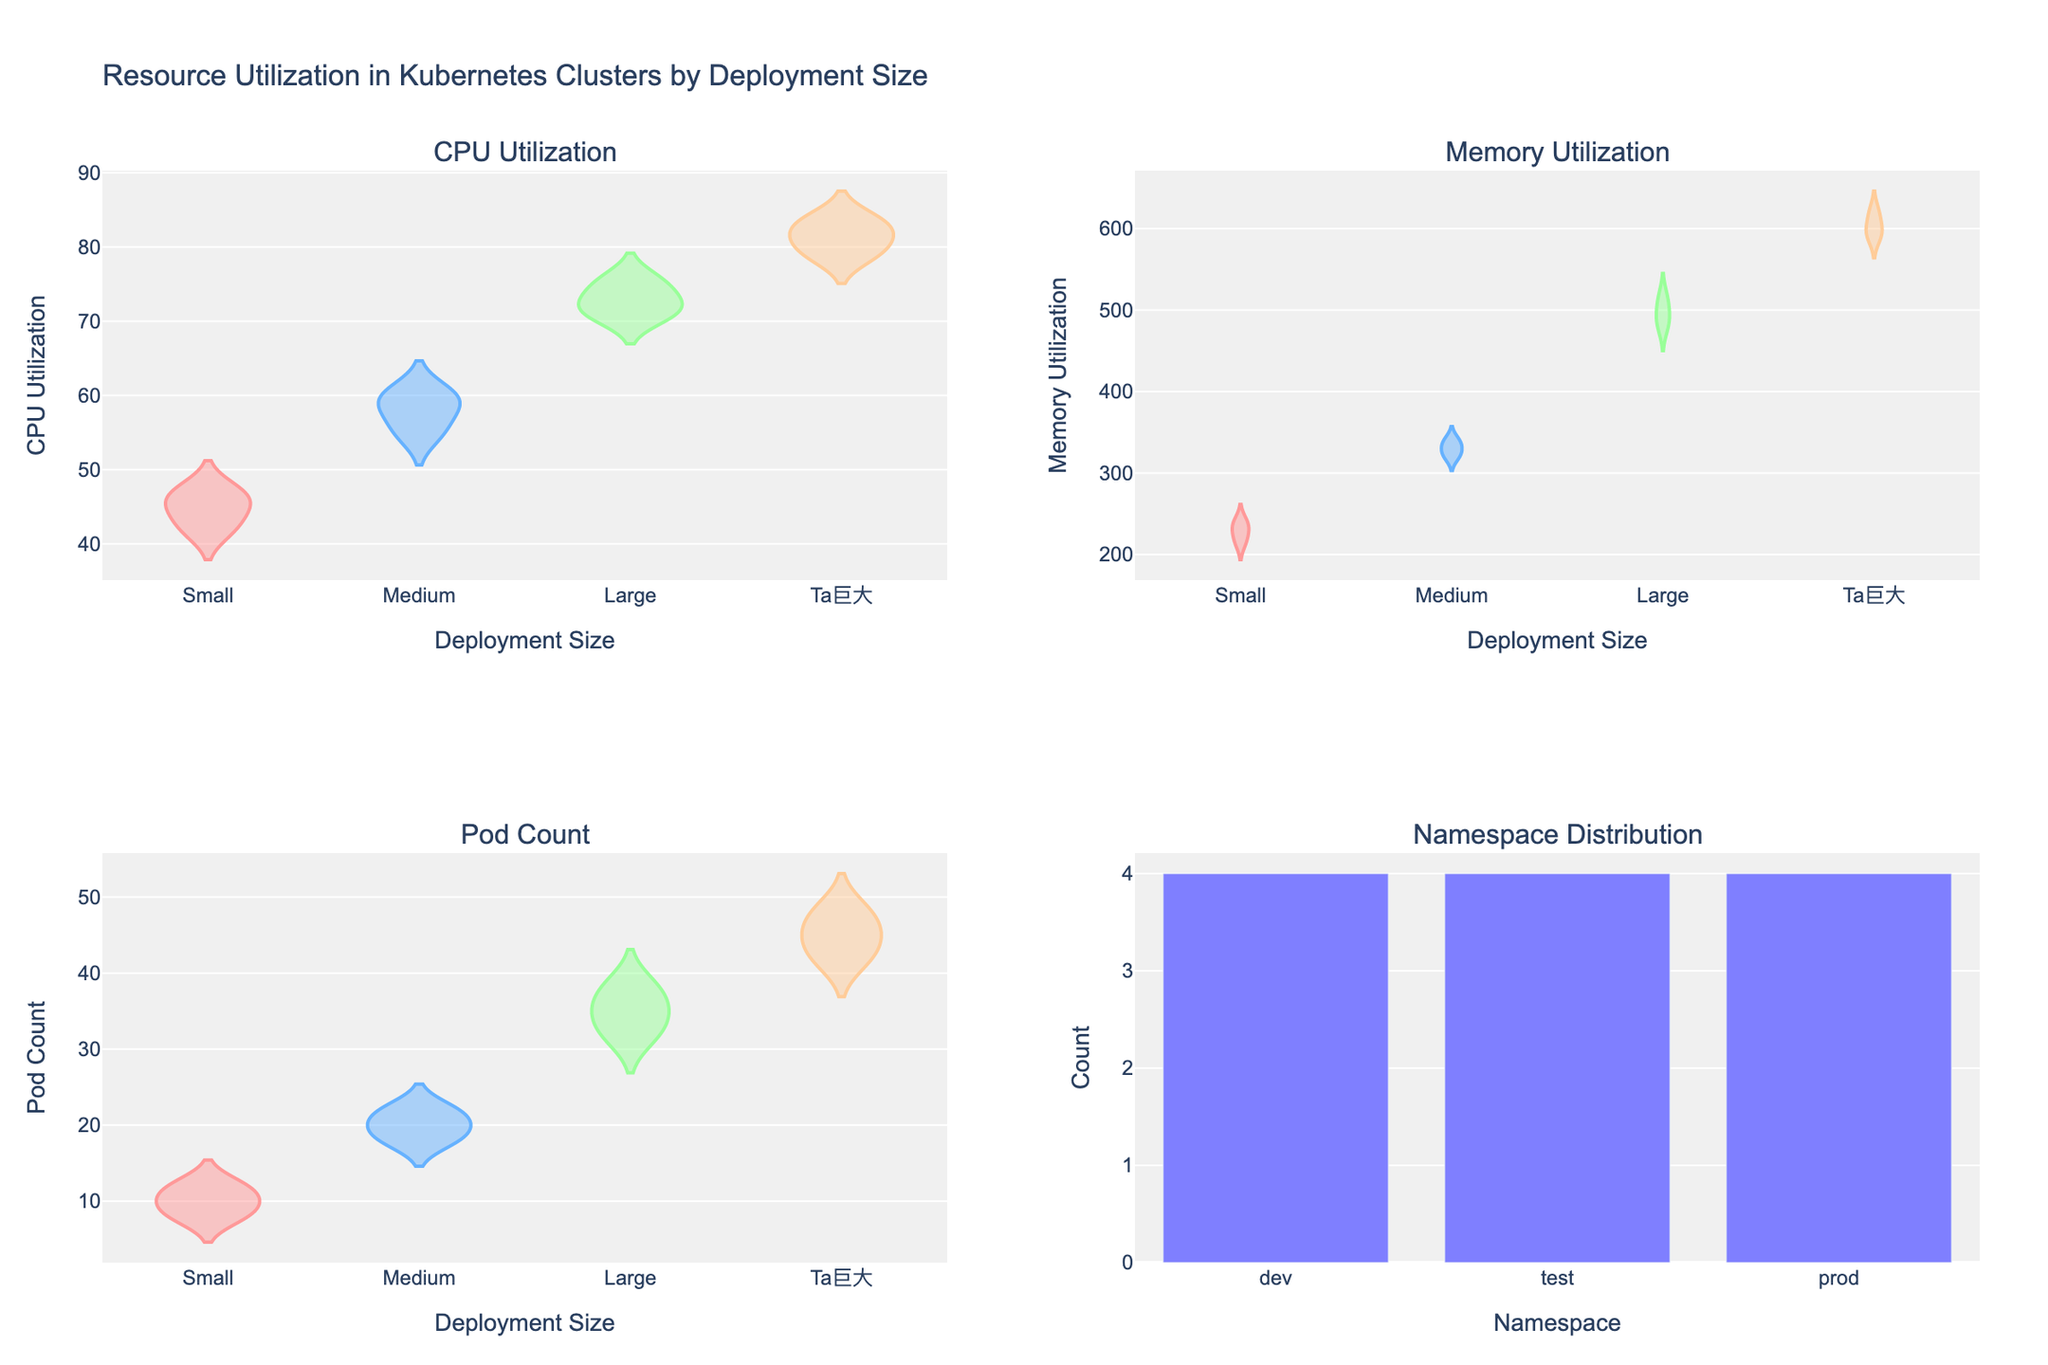What is the title of the figure? At the top of the figure, the title reads "Resource Utilization in Kubernetes Clusters by Deployment Size".
Answer: Resource Utilization in Kubernetes Clusters by Deployment Size What are the four subplots in the figure? The subplot titles indicate "CPU Utilization", "Memory Utilization", "Pod Count", and "Namespace Distribution".
Answer: CPU Utilization, Memory Utilization, Pod Count, Namespace Distribution Which deployment size group has the highest median CPU utilization? Looking at the CPU Utilization subplot, the "Ta巨大" group appears to have the highest median line.
Answer: Ta巨大 How many namespaces are visualized in the Namespace Distribution subplot? The bar plot in this subplot shows bars for "dev", "test", and "prod", indicating three namespaces.
Answer: 3 Compare the spread of Memory Utilization across the deployment sizes. Which group has the least spread? Observing the violin plots in the Memory Utilization subplot, "Small" has the least vertical spread.
Answer: Small Which deployment size consistently has the highest pod counts? Referring to the Pod Count subplot, the "Ta巨大" deployment size shows the highest and most consistent pod counts.
Answer: Ta巨大 Given the plots, what can be inferred about resource utilization as deployment size increases? The CPU and Memory Utilization increase as deployment size grows from Small to Ta巨大, indicating higher resource requirements for larger deployments.
Answer: Resource utilization increases with deployment size How does the deployment size affect the number of pods in a namespace? The Pod Count subplot shows that larger deployment sizes have higher pod counts, with "Ta巨大" having the most.
Answer: Larger deployment sizes have higher pod counts Which namespace appears the most frequently across deployment sizes? The Namespace Distribution subplot indicates "test" has the tallest bar, showing it appears most frequently.
Answer: test 